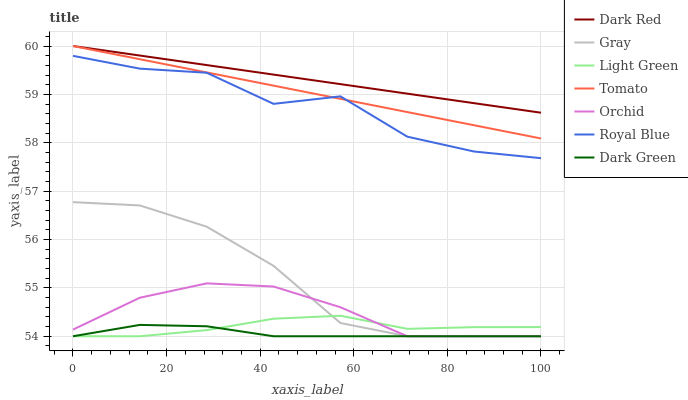Does Dark Green have the minimum area under the curve?
Answer yes or no. Yes. Does Dark Red have the maximum area under the curve?
Answer yes or no. Yes. Does Gray have the minimum area under the curve?
Answer yes or no. No. Does Gray have the maximum area under the curve?
Answer yes or no. No. Is Dark Red the smoothest?
Answer yes or no. Yes. Is Royal Blue the roughest?
Answer yes or no. Yes. Is Gray the smoothest?
Answer yes or no. No. Is Gray the roughest?
Answer yes or no. No. Does Gray have the lowest value?
Answer yes or no. Yes. Does Dark Red have the lowest value?
Answer yes or no. No. Does Dark Red have the highest value?
Answer yes or no. Yes. Does Gray have the highest value?
Answer yes or no. No. Is Orchid less than Dark Red?
Answer yes or no. Yes. Is Dark Red greater than Gray?
Answer yes or no. Yes. Does Gray intersect Dark Green?
Answer yes or no. Yes. Is Gray less than Dark Green?
Answer yes or no. No. Is Gray greater than Dark Green?
Answer yes or no. No. Does Orchid intersect Dark Red?
Answer yes or no. No. 